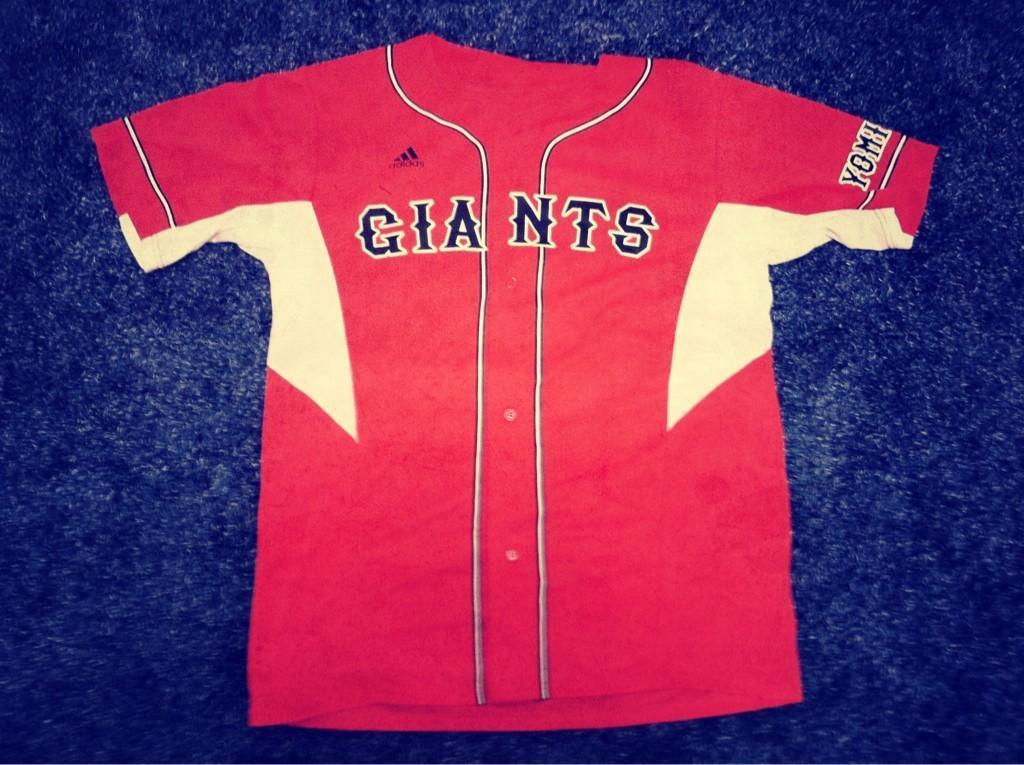<image>
Give a short and clear explanation of the subsequent image. a red and white jersey on the floor reading Giants on it 